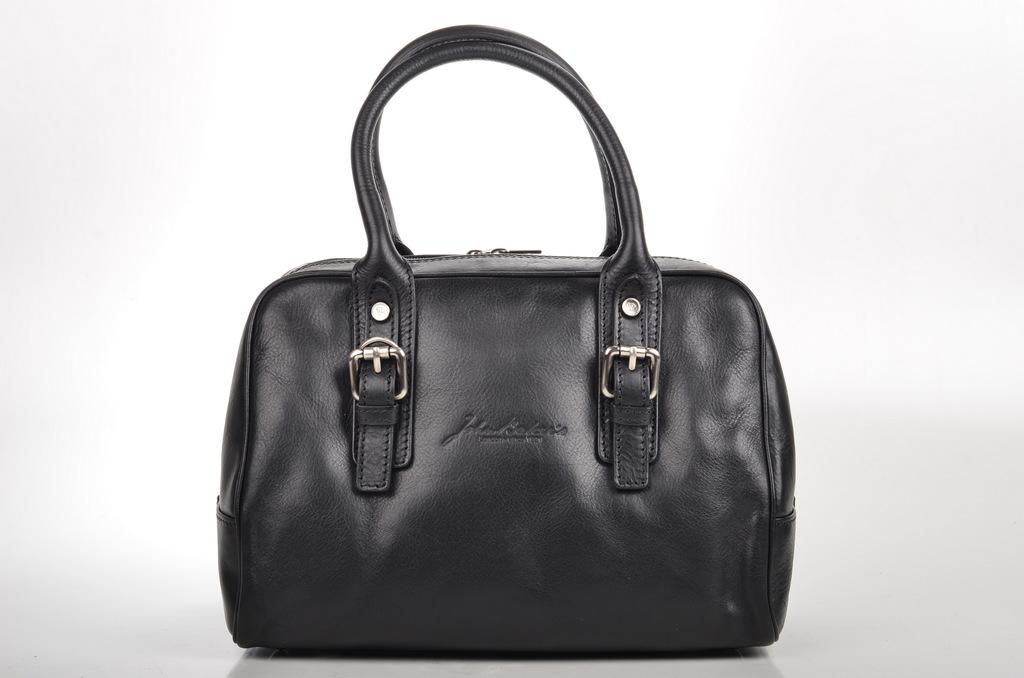What is the color of the bag that is visible in the image? There is a black bag in the image. What type of cake is visible inside the black bag in the image? There is no cake visible inside the black bag in the image. How many nails can be seen sticking out of the black bag in the image? There are no nails visible sticking out of the black bag in the image. 